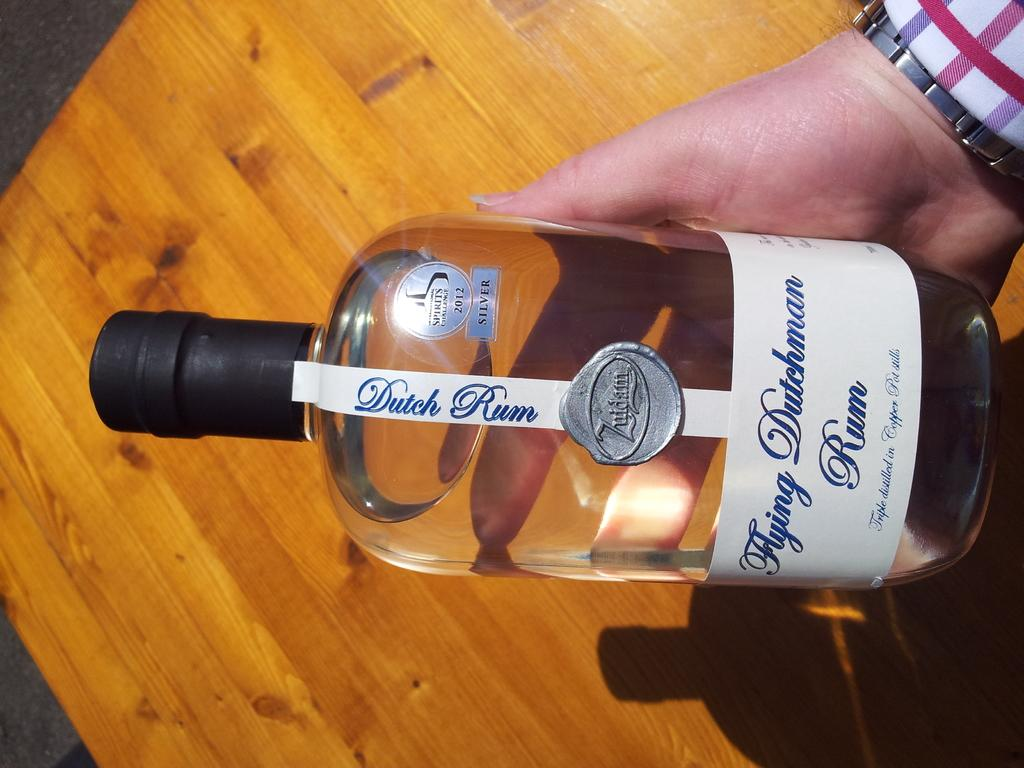<image>
Summarize the visual content of the image. A person holding a dutch rum drink in its hand. 